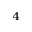Convert formula to latex. <formula><loc_0><loc_0><loc_500><loc_500>_ { 4 }</formula> 